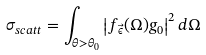<formula> <loc_0><loc_0><loc_500><loc_500>\sigma _ { s c a t t } = \int _ { \theta > \theta _ { 0 } } \left | f _ { \vec { \epsilon } } ( \Omega ) g _ { 0 } \right | ^ { 2 } d \Omega</formula> 